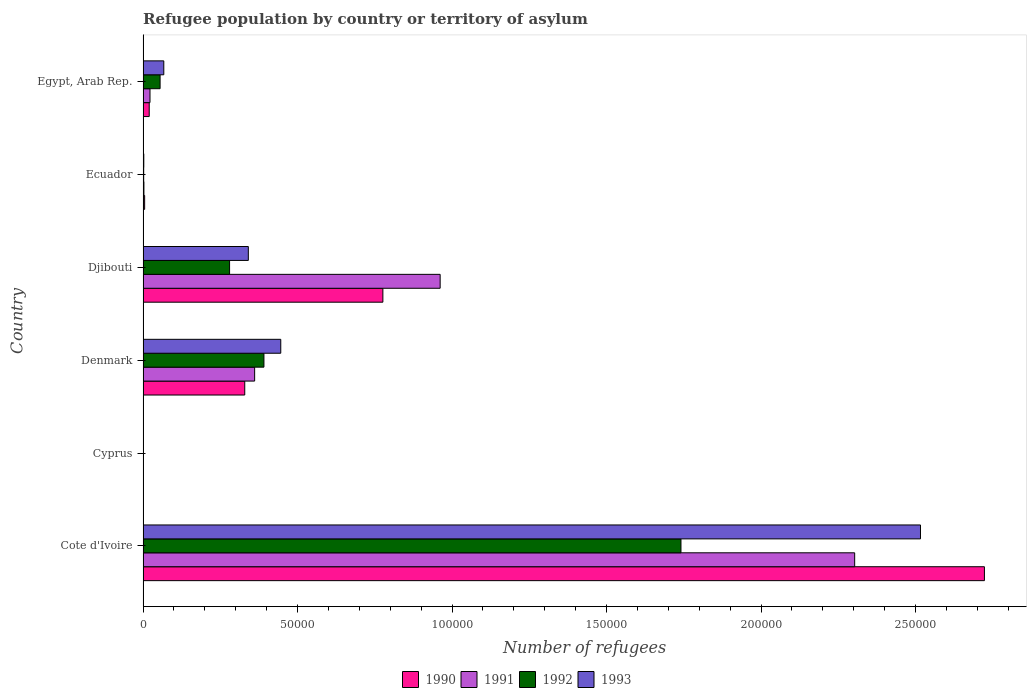How many different coloured bars are there?
Offer a very short reply. 4. Are the number of bars per tick equal to the number of legend labels?
Make the answer very short. Yes. Are the number of bars on each tick of the Y-axis equal?
Give a very brief answer. Yes. How many bars are there on the 5th tick from the bottom?
Provide a short and direct response. 4. What is the label of the 5th group of bars from the top?
Your response must be concise. Cyprus. What is the number of refugees in 1991 in Djibouti?
Your answer should be very brief. 9.61e+04. Across all countries, what is the maximum number of refugees in 1993?
Ensure brevity in your answer.  2.52e+05. In which country was the number of refugees in 1991 maximum?
Offer a very short reply. Cote d'Ivoire. In which country was the number of refugees in 1991 minimum?
Offer a very short reply. Cyprus. What is the total number of refugees in 1991 in the graph?
Keep it short and to the point. 3.65e+05. What is the difference between the number of refugees in 1990 in Ecuador and that in Egypt, Arab Rep.?
Provide a short and direct response. -1481. What is the difference between the number of refugees in 1991 in Cote d'Ivoire and the number of refugees in 1992 in Ecuador?
Ensure brevity in your answer.  2.30e+05. What is the average number of refugees in 1991 per country?
Offer a terse response. 6.09e+04. What is the difference between the number of refugees in 1993 and number of refugees in 1991 in Cote d'Ivoire?
Provide a short and direct response. 2.13e+04. What is the ratio of the number of refugees in 1993 in Ecuador to that in Egypt, Arab Rep.?
Make the answer very short. 0.04. Is the number of refugees in 1993 in Cote d'Ivoire less than that in Denmark?
Your answer should be compact. No. Is the difference between the number of refugees in 1993 in Cote d'Ivoire and Ecuador greater than the difference between the number of refugees in 1991 in Cote d'Ivoire and Ecuador?
Your response must be concise. Yes. What is the difference between the highest and the second highest number of refugees in 1993?
Provide a short and direct response. 2.07e+05. What is the difference between the highest and the lowest number of refugees in 1993?
Keep it short and to the point. 2.52e+05. In how many countries, is the number of refugees in 1992 greater than the average number of refugees in 1992 taken over all countries?
Ensure brevity in your answer.  1. Is the sum of the number of refugees in 1991 in Denmark and Djibouti greater than the maximum number of refugees in 1992 across all countries?
Make the answer very short. No. Is it the case that in every country, the sum of the number of refugees in 1991 and number of refugees in 1993 is greater than the number of refugees in 1992?
Your answer should be very brief. Yes. How many bars are there?
Your answer should be compact. 24. How many countries are there in the graph?
Your answer should be compact. 6. Where does the legend appear in the graph?
Ensure brevity in your answer.  Bottom center. How many legend labels are there?
Provide a succinct answer. 4. How are the legend labels stacked?
Keep it short and to the point. Horizontal. What is the title of the graph?
Make the answer very short. Refugee population by country or territory of asylum. What is the label or title of the X-axis?
Ensure brevity in your answer.  Number of refugees. What is the label or title of the Y-axis?
Your response must be concise. Country. What is the Number of refugees of 1990 in Cote d'Ivoire?
Give a very brief answer. 2.72e+05. What is the Number of refugees in 1991 in Cote d'Ivoire?
Give a very brief answer. 2.30e+05. What is the Number of refugees of 1992 in Cote d'Ivoire?
Offer a very short reply. 1.74e+05. What is the Number of refugees of 1993 in Cote d'Ivoire?
Your answer should be very brief. 2.52e+05. What is the Number of refugees in 1990 in Denmark?
Your answer should be compact. 3.29e+04. What is the Number of refugees of 1991 in Denmark?
Provide a short and direct response. 3.61e+04. What is the Number of refugees in 1992 in Denmark?
Your response must be concise. 3.91e+04. What is the Number of refugees of 1993 in Denmark?
Provide a succinct answer. 4.46e+04. What is the Number of refugees in 1990 in Djibouti?
Give a very brief answer. 7.76e+04. What is the Number of refugees of 1991 in Djibouti?
Provide a succinct answer. 9.61e+04. What is the Number of refugees in 1992 in Djibouti?
Offer a terse response. 2.80e+04. What is the Number of refugees in 1993 in Djibouti?
Make the answer very short. 3.41e+04. What is the Number of refugees of 1990 in Ecuador?
Offer a very short reply. 510. What is the Number of refugees in 1991 in Ecuador?
Provide a short and direct response. 280. What is the Number of refugees in 1992 in Ecuador?
Give a very brief answer. 204. What is the Number of refugees of 1993 in Ecuador?
Provide a succinct answer. 238. What is the Number of refugees of 1990 in Egypt, Arab Rep.?
Provide a succinct answer. 1991. What is the Number of refugees of 1991 in Egypt, Arab Rep.?
Ensure brevity in your answer.  2245. What is the Number of refugees in 1992 in Egypt, Arab Rep.?
Give a very brief answer. 5509. What is the Number of refugees of 1993 in Egypt, Arab Rep.?
Keep it short and to the point. 6712. Across all countries, what is the maximum Number of refugees in 1990?
Your answer should be very brief. 2.72e+05. Across all countries, what is the maximum Number of refugees of 1991?
Give a very brief answer. 2.30e+05. Across all countries, what is the maximum Number of refugees in 1992?
Provide a short and direct response. 1.74e+05. Across all countries, what is the maximum Number of refugees of 1993?
Make the answer very short. 2.52e+05. Across all countries, what is the minimum Number of refugees of 1991?
Offer a very short reply. 60. Across all countries, what is the minimum Number of refugees in 1993?
Ensure brevity in your answer.  82. What is the total Number of refugees in 1990 in the graph?
Your answer should be compact. 3.85e+05. What is the total Number of refugees in 1991 in the graph?
Provide a short and direct response. 3.65e+05. What is the total Number of refugees in 1992 in the graph?
Make the answer very short. 2.47e+05. What is the total Number of refugees in 1993 in the graph?
Offer a terse response. 3.37e+05. What is the difference between the Number of refugees in 1990 in Cote d'Ivoire and that in Cyprus?
Provide a short and direct response. 2.72e+05. What is the difference between the Number of refugees in 1991 in Cote d'Ivoire and that in Cyprus?
Give a very brief answer. 2.30e+05. What is the difference between the Number of refugees of 1992 in Cote d'Ivoire and that in Cyprus?
Provide a succinct answer. 1.74e+05. What is the difference between the Number of refugees of 1993 in Cote d'Ivoire and that in Cyprus?
Offer a very short reply. 2.52e+05. What is the difference between the Number of refugees in 1990 in Cote d'Ivoire and that in Denmark?
Keep it short and to the point. 2.39e+05. What is the difference between the Number of refugees in 1991 in Cote d'Ivoire and that in Denmark?
Your answer should be compact. 1.94e+05. What is the difference between the Number of refugees in 1992 in Cote d'Ivoire and that in Denmark?
Your answer should be very brief. 1.35e+05. What is the difference between the Number of refugees of 1993 in Cote d'Ivoire and that in Denmark?
Ensure brevity in your answer.  2.07e+05. What is the difference between the Number of refugees of 1990 in Cote d'Ivoire and that in Djibouti?
Keep it short and to the point. 1.95e+05. What is the difference between the Number of refugees in 1991 in Cote d'Ivoire and that in Djibouti?
Your response must be concise. 1.34e+05. What is the difference between the Number of refugees of 1992 in Cote d'Ivoire and that in Djibouti?
Give a very brief answer. 1.46e+05. What is the difference between the Number of refugees of 1993 in Cote d'Ivoire and that in Djibouti?
Provide a succinct answer. 2.18e+05. What is the difference between the Number of refugees in 1990 in Cote d'Ivoire and that in Ecuador?
Your answer should be very brief. 2.72e+05. What is the difference between the Number of refugees in 1991 in Cote d'Ivoire and that in Ecuador?
Ensure brevity in your answer.  2.30e+05. What is the difference between the Number of refugees in 1992 in Cote d'Ivoire and that in Ecuador?
Your answer should be compact. 1.74e+05. What is the difference between the Number of refugees of 1993 in Cote d'Ivoire and that in Ecuador?
Your answer should be very brief. 2.51e+05. What is the difference between the Number of refugees in 1990 in Cote d'Ivoire and that in Egypt, Arab Rep.?
Provide a short and direct response. 2.70e+05. What is the difference between the Number of refugees of 1991 in Cote d'Ivoire and that in Egypt, Arab Rep.?
Provide a succinct answer. 2.28e+05. What is the difference between the Number of refugees of 1992 in Cote d'Ivoire and that in Egypt, Arab Rep.?
Keep it short and to the point. 1.69e+05. What is the difference between the Number of refugees of 1993 in Cote d'Ivoire and that in Egypt, Arab Rep.?
Keep it short and to the point. 2.45e+05. What is the difference between the Number of refugees in 1990 in Cyprus and that in Denmark?
Keep it short and to the point. -3.29e+04. What is the difference between the Number of refugees of 1991 in Cyprus and that in Denmark?
Your answer should be very brief. -3.60e+04. What is the difference between the Number of refugees of 1992 in Cyprus and that in Denmark?
Your answer should be very brief. -3.90e+04. What is the difference between the Number of refugees of 1993 in Cyprus and that in Denmark?
Keep it short and to the point. -4.45e+04. What is the difference between the Number of refugees in 1990 in Cyprus and that in Djibouti?
Provide a succinct answer. -7.76e+04. What is the difference between the Number of refugees in 1991 in Cyprus and that in Djibouti?
Your response must be concise. -9.61e+04. What is the difference between the Number of refugees in 1992 in Cyprus and that in Djibouti?
Your answer should be compact. -2.79e+04. What is the difference between the Number of refugees of 1993 in Cyprus and that in Djibouti?
Your response must be concise. -3.40e+04. What is the difference between the Number of refugees of 1990 in Cyprus and that in Ecuador?
Your answer should be compact. -477. What is the difference between the Number of refugees of 1991 in Cyprus and that in Ecuador?
Offer a very short reply. -220. What is the difference between the Number of refugees in 1992 in Cyprus and that in Ecuador?
Provide a succinct answer. -124. What is the difference between the Number of refugees in 1993 in Cyprus and that in Ecuador?
Keep it short and to the point. -156. What is the difference between the Number of refugees of 1990 in Cyprus and that in Egypt, Arab Rep.?
Provide a succinct answer. -1958. What is the difference between the Number of refugees in 1991 in Cyprus and that in Egypt, Arab Rep.?
Your response must be concise. -2185. What is the difference between the Number of refugees of 1992 in Cyprus and that in Egypt, Arab Rep.?
Provide a short and direct response. -5429. What is the difference between the Number of refugees in 1993 in Cyprus and that in Egypt, Arab Rep.?
Offer a terse response. -6630. What is the difference between the Number of refugees in 1990 in Denmark and that in Djibouti?
Your response must be concise. -4.47e+04. What is the difference between the Number of refugees in 1991 in Denmark and that in Djibouti?
Provide a short and direct response. -6.00e+04. What is the difference between the Number of refugees of 1992 in Denmark and that in Djibouti?
Provide a succinct answer. 1.11e+04. What is the difference between the Number of refugees of 1993 in Denmark and that in Djibouti?
Ensure brevity in your answer.  1.05e+04. What is the difference between the Number of refugees in 1990 in Denmark and that in Ecuador?
Keep it short and to the point. 3.24e+04. What is the difference between the Number of refugees of 1991 in Denmark and that in Ecuador?
Your response must be concise. 3.58e+04. What is the difference between the Number of refugees of 1992 in Denmark and that in Ecuador?
Your answer should be very brief. 3.89e+04. What is the difference between the Number of refugees of 1993 in Denmark and that in Ecuador?
Provide a succinct answer. 4.43e+04. What is the difference between the Number of refugees of 1990 in Denmark and that in Egypt, Arab Rep.?
Ensure brevity in your answer.  3.09e+04. What is the difference between the Number of refugees of 1991 in Denmark and that in Egypt, Arab Rep.?
Give a very brief answer. 3.39e+04. What is the difference between the Number of refugees in 1992 in Denmark and that in Egypt, Arab Rep.?
Your response must be concise. 3.36e+04. What is the difference between the Number of refugees of 1993 in Denmark and that in Egypt, Arab Rep.?
Provide a succinct answer. 3.79e+04. What is the difference between the Number of refugees in 1990 in Djibouti and that in Ecuador?
Provide a short and direct response. 7.71e+04. What is the difference between the Number of refugees in 1991 in Djibouti and that in Ecuador?
Give a very brief answer. 9.59e+04. What is the difference between the Number of refugees in 1992 in Djibouti and that in Ecuador?
Offer a very short reply. 2.78e+04. What is the difference between the Number of refugees of 1993 in Djibouti and that in Ecuador?
Offer a very short reply. 3.38e+04. What is the difference between the Number of refugees of 1990 in Djibouti and that in Egypt, Arab Rep.?
Ensure brevity in your answer.  7.56e+04. What is the difference between the Number of refugees in 1991 in Djibouti and that in Egypt, Arab Rep.?
Provide a succinct answer. 9.39e+04. What is the difference between the Number of refugees in 1992 in Djibouti and that in Egypt, Arab Rep.?
Offer a terse response. 2.25e+04. What is the difference between the Number of refugees in 1993 in Djibouti and that in Egypt, Arab Rep.?
Provide a short and direct response. 2.74e+04. What is the difference between the Number of refugees in 1990 in Ecuador and that in Egypt, Arab Rep.?
Provide a succinct answer. -1481. What is the difference between the Number of refugees in 1991 in Ecuador and that in Egypt, Arab Rep.?
Ensure brevity in your answer.  -1965. What is the difference between the Number of refugees of 1992 in Ecuador and that in Egypt, Arab Rep.?
Make the answer very short. -5305. What is the difference between the Number of refugees of 1993 in Ecuador and that in Egypt, Arab Rep.?
Ensure brevity in your answer.  -6474. What is the difference between the Number of refugees in 1990 in Cote d'Ivoire and the Number of refugees in 1991 in Cyprus?
Offer a very short reply. 2.72e+05. What is the difference between the Number of refugees in 1990 in Cote d'Ivoire and the Number of refugees in 1992 in Cyprus?
Ensure brevity in your answer.  2.72e+05. What is the difference between the Number of refugees of 1990 in Cote d'Ivoire and the Number of refugees of 1993 in Cyprus?
Ensure brevity in your answer.  2.72e+05. What is the difference between the Number of refugees of 1991 in Cote d'Ivoire and the Number of refugees of 1992 in Cyprus?
Your response must be concise. 2.30e+05. What is the difference between the Number of refugees of 1991 in Cote d'Ivoire and the Number of refugees of 1993 in Cyprus?
Make the answer very short. 2.30e+05. What is the difference between the Number of refugees of 1992 in Cote d'Ivoire and the Number of refugees of 1993 in Cyprus?
Your response must be concise. 1.74e+05. What is the difference between the Number of refugees in 1990 in Cote d'Ivoire and the Number of refugees in 1991 in Denmark?
Provide a short and direct response. 2.36e+05. What is the difference between the Number of refugees in 1990 in Cote d'Ivoire and the Number of refugees in 1992 in Denmark?
Offer a terse response. 2.33e+05. What is the difference between the Number of refugees of 1990 in Cote d'Ivoire and the Number of refugees of 1993 in Denmark?
Your answer should be very brief. 2.28e+05. What is the difference between the Number of refugees in 1991 in Cote d'Ivoire and the Number of refugees in 1992 in Denmark?
Your answer should be compact. 1.91e+05. What is the difference between the Number of refugees in 1991 in Cote d'Ivoire and the Number of refugees in 1993 in Denmark?
Give a very brief answer. 1.86e+05. What is the difference between the Number of refugees in 1992 in Cote d'Ivoire and the Number of refugees in 1993 in Denmark?
Ensure brevity in your answer.  1.30e+05. What is the difference between the Number of refugees of 1990 in Cote d'Ivoire and the Number of refugees of 1991 in Djibouti?
Your answer should be very brief. 1.76e+05. What is the difference between the Number of refugees in 1990 in Cote d'Ivoire and the Number of refugees in 1992 in Djibouti?
Keep it short and to the point. 2.44e+05. What is the difference between the Number of refugees of 1990 in Cote d'Ivoire and the Number of refugees of 1993 in Djibouti?
Your response must be concise. 2.38e+05. What is the difference between the Number of refugees of 1991 in Cote d'Ivoire and the Number of refugees of 1992 in Djibouti?
Offer a very short reply. 2.02e+05. What is the difference between the Number of refugees in 1991 in Cote d'Ivoire and the Number of refugees in 1993 in Djibouti?
Provide a short and direct response. 1.96e+05. What is the difference between the Number of refugees of 1992 in Cote d'Ivoire and the Number of refugees of 1993 in Djibouti?
Make the answer very short. 1.40e+05. What is the difference between the Number of refugees in 1990 in Cote d'Ivoire and the Number of refugees in 1991 in Ecuador?
Your answer should be very brief. 2.72e+05. What is the difference between the Number of refugees in 1990 in Cote d'Ivoire and the Number of refugees in 1992 in Ecuador?
Keep it short and to the point. 2.72e+05. What is the difference between the Number of refugees in 1990 in Cote d'Ivoire and the Number of refugees in 1993 in Ecuador?
Offer a very short reply. 2.72e+05. What is the difference between the Number of refugees in 1991 in Cote d'Ivoire and the Number of refugees in 1992 in Ecuador?
Offer a very short reply. 2.30e+05. What is the difference between the Number of refugees of 1991 in Cote d'Ivoire and the Number of refugees of 1993 in Ecuador?
Give a very brief answer. 2.30e+05. What is the difference between the Number of refugees of 1992 in Cote d'Ivoire and the Number of refugees of 1993 in Ecuador?
Ensure brevity in your answer.  1.74e+05. What is the difference between the Number of refugees of 1990 in Cote d'Ivoire and the Number of refugees of 1991 in Egypt, Arab Rep.?
Provide a succinct answer. 2.70e+05. What is the difference between the Number of refugees of 1990 in Cote d'Ivoire and the Number of refugees of 1992 in Egypt, Arab Rep.?
Provide a short and direct response. 2.67e+05. What is the difference between the Number of refugees in 1990 in Cote d'Ivoire and the Number of refugees in 1993 in Egypt, Arab Rep.?
Offer a very short reply. 2.66e+05. What is the difference between the Number of refugees of 1991 in Cote d'Ivoire and the Number of refugees of 1992 in Egypt, Arab Rep.?
Provide a short and direct response. 2.25e+05. What is the difference between the Number of refugees of 1991 in Cote d'Ivoire and the Number of refugees of 1993 in Egypt, Arab Rep.?
Make the answer very short. 2.24e+05. What is the difference between the Number of refugees of 1992 in Cote d'Ivoire and the Number of refugees of 1993 in Egypt, Arab Rep.?
Keep it short and to the point. 1.67e+05. What is the difference between the Number of refugees of 1990 in Cyprus and the Number of refugees of 1991 in Denmark?
Your answer should be compact. -3.61e+04. What is the difference between the Number of refugees of 1990 in Cyprus and the Number of refugees of 1992 in Denmark?
Offer a very short reply. -3.91e+04. What is the difference between the Number of refugees in 1990 in Cyprus and the Number of refugees in 1993 in Denmark?
Ensure brevity in your answer.  -4.45e+04. What is the difference between the Number of refugees in 1991 in Cyprus and the Number of refugees in 1992 in Denmark?
Keep it short and to the point. -3.91e+04. What is the difference between the Number of refugees of 1991 in Cyprus and the Number of refugees of 1993 in Denmark?
Your answer should be compact. -4.45e+04. What is the difference between the Number of refugees of 1992 in Cyprus and the Number of refugees of 1993 in Denmark?
Provide a succinct answer. -4.45e+04. What is the difference between the Number of refugees of 1990 in Cyprus and the Number of refugees of 1991 in Djibouti?
Provide a short and direct response. -9.61e+04. What is the difference between the Number of refugees in 1990 in Cyprus and the Number of refugees in 1992 in Djibouti?
Provide a succinct answer. -2.80e+04. What is the difference between the Number of refugees of 1990 in Cyprus and the Number of refugees of 1993 in Djibouti?
Offer a very short reply. -3.40e+04. What is the difference between the Number of refugees in 1991 in Cyprus and the Number of refugees in 1992 in Djibouti?
Provide a succinct answer. -2.79e+04. What is the difference between the Number of refugees of 1991 in Cyprus and the Number of refugees of 1993 in Djibouti?
Your response must be concise. -3.40e+04. What is the difference between the Number of refugees in 1992 in Cyprus and the Number of refugees in 1993 in Djibouti?
Offer a very short reply. -3.40e+04. What is the difference between the Number of refugees of 1990 in Cyprus and the Number of refugees of 1991 in Ecuador?
Offer a terse response. -247. What is the difference between the Number of refugees of 1990 in Cyprus and the Number of refugees of 1992 in Ecuador?
Ensure brevity in your answer.  -171. What is the difference between the Number of refugees in 1990 in Cyprus and the Number of refugees in 1993 in Ecuador?
Your answer should be very brief. -205. What is the difference between the Number of refugees of 1991 in Cyprus and the Number of refugees of 1992 in Ecuador?
Keep it short and to the point. -144. What is the difference between the Number of refugees of 1991 in Cyprus and the Number of refugees of 1993 in Ecuador?
Provide a short and direct response. -178. What is the difference between the Number of refugees of 1992 in Cyprus and the Number of refugees of 1993 in Ecuador?
Provide a succinct answer. -158. What is the difference between the Number of refugees of 1990 in Cyprus and the Number of refugees of 1991 in Egypt, Arab Rep.?
Keep it short and to the point. -2212. What is the difference between the Number of refugees of 1990 in Cyprus and the Number of refugees of 1992 in Egypt, Arab Rep.?
Your answer should be very brief. -5476. What is the difference between the Number of refugees in 1990 in Cyprus and the Number of refugees in 1993 in Egypt, Arab Rep.?
Make the answer very short. -6679. What is the difference between the Number of refugees of 1991 in Cyprus and the Number of refugees of 1992 in Egypt, Arab Rep.?
Your response must be concise. -5449. What is the difference between the Number of refugees of 1991 in Cyprus and the Number of refugees of 1993 in Egypt, Arab Rep.?
Ensure brevity in your answer.  -6652. What is the difference between the Number of refugees in 1992 in Cyprus and the Number of refugees in 1993 in Egypt, Arab Rep.?
Ensure brevity in your answer.  -6632. What is the difference between the Number of refugees of 1990 in Denmark and the Number of refugees of 1991 in Djibouti?
Provide a short and direct response. -6.32e+04. What is the difference between the Number of refugees of 1990 in Denmark and the Number of refugees of 1992 in Djibouti?
Offer a very short reply. 4906. What is the difference between the Number of refugees of 1990 in Denmark and the Number of refugees of 1993 in Djibouti?
Keep it short and to the point. -1159. What is the difference between the Number of refugees in 1991 in Denmark and the Number of refugees in 1992 in Djibouti?
Keep it short and to the point. 8110. What is the difference between the Number of refugees in 1991 in Denmark and the Number of refugees in 1993 in Djibouti?
Keep it short and to the point. 2045. What is the difference between the Number of refugees in 1992 in Denmark and the Number of refugees in 1993 in Djibouti?
Make the answer very short. 5053. What is the difference between the Number of refugees in 1990 in Denmark and the Number of refugees in 1991 in Ecuador?
Provide a succinct answer. 3.26e+04. What is the difference between the Number of refugees in 1990 in Denmark and the Number of refugees in 1992 in Ecuador?
Ensure brevity in your answer.  3.27e+04. What is the difference between the Number of refugees in 1990 in Denmark and the Number of refugees in 1993 in Ecuador?
Keep it short and to the point. 3.27e+04. What is the difference between the Number of refugees in 1991 in Denmark and the Number of refugees in 1992 in Ecuador?
Your answer should be very brief. 3.59e+04. What is the difference between the Number of refugees in 1991 in Denmark and the Number of refugees in 1993 in Ecuador?
Ensure brevity in your answer.  3.59e+04. What is the difference between the Number of refugees in 1992 in Denmark and the Number of refugees in 1993 in Ecuador?
Give a very brief answer. 3.89e+04. What is the difference between the Number of refugees of 1990 in Denmark and the Number of refugees of 1991 in Egypt, Arab Rep.?
Give a very brief answer. 3.07e+04. What is the difference between the Number of refugees of 1990 in Denmark and the Number of refugees of 1992 in Egypt, Arab Rep.?
Provide a short and direct response. 2.74e+04. What is the difference between the Number of refugees in 1990 in Denmark and the Number of refugees in 1993 in Egypt, Arab Rep.?
Your answer should be compact. 2.62e+04. What is the difference between the Number of refugees in 1991 in Denmark and the Number of refugees in 1992 in Egypt, Arab Rep.?
Your answer should be very brief. 3.06e+04. What is the difference between the Number of refugees in 1991 in Denmark and the Number of refugees in 1993 in Egypt, Arab Rep.?
Provide a short and direct response. 2.94e+04. What is the difference between the Number of refugees of 1992 in Denmark and the Number of refugees of 1993 in Egypt, Arab Rep.?
Your response must be concise. 3.24e+04. What is the difference between the Number of refugees of 1990 in Djibouti and the Number of refugees of 1991 in Ecuador?
Offer a terse response. 7.73e+04. What is the difference between the Number of refugees of 1990 in Djibouti and the Number of refugees of 1992 in Ecuador?
Offer a very short reply. 7.74e+04. What is the difference between the Number of refugees of 1990 in Djibouti and the Number of refugees of 1993 in Ecuador?
Your response must be concise. 7.74e+04. What is the difference between the Number of refugees of 1991 in Djibouti and the Number of refugees of 1992 in Ecuador?
Keep it short and to the point. 9.59e+04. What is the difference between the Number of refugees in 1991 in Djibouti and the Number of refugees in 1993 in Ecuador?
Provide a short and direct response. 9.59e+04. What is the difference between the Number of refugees of 1992 in Djibouti and the Number of refugees of 1993 in Ecuador?
Your answer should be compact. 2.78e+04. What is the difference between the Number of refugees of 1990 in Djibouti and the Number of refugees of 1991 in Egypt, Arab Rep.?
Ensure brevity in your answer.  7.54e+04. What is the difference between the Number of refugees of 1990 in Djibouti and the Number of refugees of 1992 in Egypt, Arab Rep.?
Offer a terse response. 7.21e+04. What is the difference between the Number of refugees of 1990 in Djibouti and the Number of refugees of 1993 in Egypt, Arab Rep.?
Offer a terse response. 7.09e+04. What is the difference between the Number of refugees in 1991 in Djibouti and the Number of refugees in 1992 in Egypt, Arab Rep.?
Your answer should be very brief. 9.06e+04. What is the difference between the Number of refugees in 1991 in Djibouti and the Number of refugees in 1993 in Egypt, Arab Rep.?
Offer a terse response. 8.94e+04. What is the difference between the Number of refugees in 1992 in Djibouti and the Number of refugees in 1993 in Egypt, Arab Rep.?
Your answer should be compact. 2.13e+04. What is the difference between the Number of refugees in 1990 in Ecuador and the Number of refugees in 1991 in Egypt, Arab Rep.?
Your response must be concise. -1735. What is the difference between the Number of refugees in 1990 in Ecuador and the Number of refugees in 1992 in Egypt, Arab Rep.?
Offer a terse response. -4999. What is the difference between the Number of refugees of 1990 in Ecuador and the Number of refugees of 1993 in Egypt, Arab Rep.?
Your response must be concise. -6202. What is the difference between the Number of refugees in 1991 in Ecuador and the Number of refugees in 1992 in Egypt, Arab Rep.?
Your response must be concise. -5229. What is the difference between the Number of refugees in 1991 in Ecuador and the Number of refugees in 1993 in Egypt, Arab Rep.?
Provide a succinct answer. -6432. What is the difference between the Number of refugees in 1992 in Ecuador and the Number of refugees in 1993 in Egypt, Arab Rep.?
Make the answer very short. -6508. What is the average Number of refugees of 1990 per country?
Give a very brief answer. 6.42e+04. What is the average Number of refugees of 1991 per country?
Offer a very short reply. 6.09e+04. What is the average Number of refugees in 1992 per country?
Your response must be concise. 4.12e+04. What is the average Number of refugees of 1993 per country?
Keep it short and to the point. 5.62e+04. What is the difference between the Number of refugees in 1990 and Number of refugees in 1991 in Cote d'Ivoire?
Keep it short and to the point. 4.20e+04. What is the difference between the Number of refugees of 1990 and Number of refugees of 1992 in Cote d'Ivoire?
Make the answer very short. 9.82e+04. What is the difference between the Number of refugees of 1990 and Number of refugees of 1993 in Cote d'Ivoire?
Your answer should be very brief. 2.07e+04. What is the difference between the Number of refugees of 1991 and Number of refugees of 1992 in Cote d'Ivoire?
Your answer should be compact. 5.62e+04. What is the difference between the Number of refugees in 1991 and Number of refugees in 1993 in Cote d'Ivoire?
Give a very brief answer. -2.13e+04. What is the difference between the Number of refugees of 1992 and Number of refugees of 1993 in Cote d'Ivoire?
Your response must be concise. -7.75e+04. What is the difference between the Number of refugees in 1990 and Number of refugees in 1992 in Cyprus?
Keep it short and to the point. -47. What is the difference between the Number of refugees in 1990 and Number of refugees in 1993 in Cyprus?
Offer a very short reply. -49. What is the difference between the Number of refugees of 1991 and Number of refugees of 1992 in Cyprus?
Ensure brevity in your answer.  -20. What is the difference between the Number of refugees of 1991 and Number of refugees of 1993 in Cyprus?
Your response must be concise. -22. What is the difference between the Number of refugees of 1990 and Number of refugees of 1991 in Denmark?
Your answer should be compact. -3204. What is the difference between the Number of refugees of 1990 and Number of refugees of 1992 in Denmark?
Keep it short and to the point. -6212. What is the difference between the Number of refugees in 1990 and Number of refugees in 1993 in Denmark?
Offer a terse response. -1.17e+04. What is the difference between the Number of refugees of 1991 and Number of refugees of 1992 in Denmark?
Offer a terse response. -3008. What is the difference between the Number of refugees in 1991 and Number of refugees in 1993 in Denmark?
Offer a terse response. -8454. What is the difference between the Number of refugees of 1992 and Number of refugees of 1993 in Denmark?
Offer a terse response. -5446. What is the difference between the Number of refugees of 1990 and Number of refugees of 1991 in Djibouti?
Offer a terse response. -1.85e+04. What is the difference between the Number of refugees in 1990 and Number of refugees in 1992 in Djibouti?
Keep it short and to the point. 4.96e+04. What is the difference between the Number of refugees in 1990 and Number of refugees in 1993 in Djibouti?
Offer a terse response. 4.35e+04. What is the difference between the Number of refugees of 1991 and Number of refugees of 1992 in Djibouti?
Offer a terse response. 6.81e+04. What is the difference between the Number of refugees in 1991 and Number of refugees in 1993 in Djibouti?
Ensure brevity in your answer.  6.21e+04. What is the difference between the Number of refugees in 1992 and Number of refugees in 1993 in Djibouti?
Provide a short and direct response. -6065. What is the difference between the Number of refugees in 1990 and Number of refugees in 1991 in Ecuador?
Make the answer very short. 230. What is the difference between the Number of refugees of 1990 and Number of refugees of 1992 in Ecuador?
Your answer should be compact. 306. What is the difference between the Number of refugees of 1990 and Number of refugees of 1993 in Ecuador?
Make the answer very short. 272. What is the difference between the Number of refugees of 1992 and Number of refugees of 1993 in Ecuador?
Your answer should be very brief. -34. What is the difference between the Number of refugees of 1990 and Number of refugees of 1991 in Egypt, Arab Rep.?
Your response must be concise. -254. What is the difference between the Number of refugees of 1990 and Number of refugees of 1992 in Egypt, Arab Rep.?
Your answer should be very brief. -3518. What is the difference between the Number of refugees of 1990 and Number of refugees of 1993 in Egypt, Arab Rep.?
Give a very brief answer. -4721. What is the difference between the Number of refugees of 1991 and Number of refugees of 1992 in Egypt, Arab Rep.?
Offer a terse response. -3264. What is the difference between the Number of refugees in 1991 and Number of refugees in 1993 in Egypt, Arab Rep.?
Provide a succinct answer. -4467. What is the difference between the Number of refugees in 1992 and Number of refugees in 1993 in Egypt, Arab Rep.?
Provide a short and direct response. -1203. What is the ratio of the Number of refugees in 1990 in Cote d'Ivoire to that in Cyprus?
Give a very brief answer. 8250.94. What is the ratio of the Number of refugees in 1991 in Cote d'Ivoire to that in Cyprus?
Make the answer very short. 3838.17. What is the ratio of the Number of refugees in 1992 in Cote d'Ivoire to that in Cyprus?
Give a very brief answer. 2175.95. What is the ratio of the Number of refugees of 1993 in Cote d'Ivoire to that in Cyprus?
Your answer should be compact. 3068.15. What is the ratio of the Number of refugees in 1990 in Cote d'Ivoire to that in Denmark?
Make the answer very short. 8.27. What is the ratio of the Number of refugees of 1991 in Cote d'Ivoire to that in Denmark?
Ensure brevity in your answer.  6.38. What is the ratio of the Number of refugees of 1992 in Cote d'Ivoire to that in Denmark?
Offer a very short reply. 4.45. What is the ratio of the Number of refugees of 1993 in Cote d'Ivoire to that in Denmark?
Offer a very short reply. 5.65. What is the ratio of the Number of refugees in 1990 in Cote d'Ivoire to that in Djibouti?
Keep it short and to the point. 3.51. What is the ratio of the Number of refugees in 1991 in Cote d'Ivoire to that in Djibouti?
Ensure brevity in your answer.  2.4. What is the ratio of the Number of refugees in 1992 in Cote d'Ivoire to that in Djibouti?
Provide a succinct answer. 6.22. What is the ratio of the Number of refugees in 1993 in Cote d'Ivoire to that in Djibouti?
Provide a succinct answer. 7.39. What is the ratio of the Number of refugees in 1990 in Cote d'Ivoire to that in Ecuador?
Offer a very short reply. 533.88. What is the ratio of the Number of refugees of 1991 in Cote d'Ivoire to that in Ecuador?
Keep it short and to the point. 822.46. What is the ratio of the Number of refugees in 1992 in Cote d'Ivoire to that in Ecuador?
Offer a terse response. 853.31. What is the ratio of the Number of refugees in 1993 in Cote d'Ivoire to that in Ecuador?
Your response must be concise. 1057.09. What is the ratio of the Number of refugees of 1990 in Cote d'Ivoire to that in Egypt, Arab Rep.?
Offer a very short reply. 136.76. What is the ratio of the Number of refugees in 1991 in Cote d'Ivoire to that in Egypt, Arab Rep.?
Provide a succinct answer. 102.58. What is the ratio of the Number of refugees in 1992 in Cote d'Ivoire to that in Egypt, Arab Rep.?
Give a very brief answer. 31.6. What is the ratio of the Number of refugees in 1993 in Cote d'Ivoire to that in Egypt, Arab Rep.?
Your response must be concise. 37.48. What is the ratio of the Number of refugees of 1990 in Cyprus to that in Denmark?
Make the answer very short. 0. What is the ratio of the Number of refugees of 1991 in Cyprus to that in Denmark?
Your answer should be very brief. 0. What is the ratio of the Number of refugees in 1992 in Cyprus to that in Denmark?
Give a very brief answer. 0. What is the ratio of the Number of refugees of 1993 in Cyprus to that in Denmark?
Provide a short and direct response. 0. What is the ratio of the Number of refugees of 1991 in Cyprus to that in Djibouti?
Provide a short and direct response. 0. What is the ratio of the Number of refugees of 1992 in Cyprus to that in Djibouti?
Your answer should be very brief. 0. What is the ratio of the Number of refugees in 1993 in Cyprus to that in Djibouti?
Give a very brief answer. 0. What is the ratio of the Number of refugees of 1990 in Cyprus to that in Ecuador?
Offer a very short reply. 0.06. What is the ratio of the Number of refugees in 1991 in Cyprus to that in Ecuador?
Keep it short and to the point. 0.21. What is the ratio of the Number of refugees in 1992 in Cyprus to that in Ecuador?
Ensure brevity in your answer.  0.39. What is the ratio of the Number of refugees in 1993 in Cyprus to that in Ecuador?
Keep it short and to the point. 0.34. What is the ratio of the Number of refugees of 1990 in Cyprus to that in Egypt, Arab Rep.?
Provide a succinct answer. 0.02. What is the ratio of the Number of refugees in 1991 in Cyprus to that in Egypt, Arab Rep.?
Offer a terse response. 0.03. What is the ratio of the Number of refugees in 1992 in Cyprus to that in Egypt, Arab Rep.?
Offer a terse response. 0.01. What is the ratio of the Number of refugees of 1993 in Cyprus to that in Egypt, Arab Rep.?
Ensure brevity in your answer.  0.01. What is the ratio of the Number of refugees of 1990 in Denmark to that in Djibouti?
Offer a very short reply. 0.42. What is the ratio of the Number of refugees in 1991 in Denmark to that in Djibouti?
Offer a terse response. 0.38. What is the ratio of the Number of refugees of 1992 in Denmark to that in Djibouti?
Offer a very short reply. 1.4. What is the ratio of the Number of refugees of 1993 in Denmark to that in Djibouti?
Keep it short and to the point. 1.31. What is the ratio of the Number of refugees of 1990 in Denmark to that in Ecuador?
Your response must be concise. 64.52. What is the ratio of the Number of refugees in 1991 in Denmark to that in Ecuador?
Your response must be concise. 128.96. What is the ratio of the Number of refugees in 1992 in Denmark to that in Ecuador?
Offer a very short reply. 191.75. What is the ratio of the Number of refugees in 1993 in Denmark to that in Ecuador?
Keep it short and to the point. 187.24. What is the ratio of the Number of refugees in 1990 in Denmark to that in Egypt, Arab Rep.?
Your answer should be very brief. 16.53. What is the ratio of the Number of refugees in 1991 in Denmark to that in Egypt, Arab Rep.?
Offer a very short reply. 16.08. What is the ratio of the Number of refugees of 1992 in Denmark to that in Egypt, Arab Rep.?
Provide a succinct answer. 7.1. What is the ratio of the Number of refugees of 1993 in Denmark to that in Egypt, Arab Rep.?
Offer a very short reply. 6.64. What is the ratio of the Number of refugees of 1990 in Djibouti to that in Ecuador?
Keep it short and to the point. 152.17. What is the ratio of the Number of refugees of 1991 in Djibouti to that in Ecuador?
Your answer should be compact. 343.37. What is the ratio of the Number of refugees of 1992 in Djibouti to that in Ecuador?
Provide a short and direct response. 137.25. What is the ratio of the Number of refugees in 1993 in Djibouti to that in Ecuador?
Offer a terse response. 143.13. What is the ratio of the Number of refugees in 1990 in Djibouti to that in Egypt, Arab Rep.?
Your response must be concise. 38.98. What is the ratio of the Number of refugees of 1991 in Djibouti to that in Egypt, Arab Rep.?
Your response must be concise. 42.83. What is the ratio of the Number of refugees of 1992 in Djibouti to that in Egypt, Arab Rep.?
Make the answer very short. 5.08. What is the ratio of the Number of refugees of 1993 in Djibouti to that in Egypt, Arab Rep.?
Ensure brevity in your answer.  5.08. What is the ratio of the Number of refugees of 1990 in Ecuador to that in Egypt, Arab Rep.?
Provide a succinct answer. 0.26. What is the ratio of the Number of refugees in 1991 in Ecuador to that in Egypt, Arab Rep.?
Keep it short and to the point. 0.12. What is the ratio of the Number of refugees of 1992 in Ecuador to that in Egypt, Arab Rep.?
Provide a short and direct response. 0.04. What is the ratio of the Number of refugees of 1993 in Ecuador to that in Egypt, Arab Rep.?
Your answer should be compact. 0.04. What is the difference between the highest and the second highest Number of refugees in 1990?
Provide a short and direct response. 1.95e+05. What is the difference between the highest and the second highest Number of refugees of 1991?
Make the answer very short. 1.34e+05. What is the difference between the highest and the second highest Number of refugees of 1992?
Your answer should be very brief. 1.35e+05. What is the difference between the highest and the second highest Number of refugees of 1993?
Provide a succinct answer. 2.07e+05. What is the difference between the highest and the lowest Number of refugees of 1990?
Keep it short and to the point. 2.72e+05. What is the difference between the highest and the lowest Number of refugees of 1991?
Give a very brief answer. 2.30e+05. What is the difference between the highest and the lowest Number of refugees of 1992?
Provide a succinct answer. 1.74e+05. What is the difference between the highest and the lowest Number of refugees of 1993?
Provide a succinct answer. 2.52e+05. 